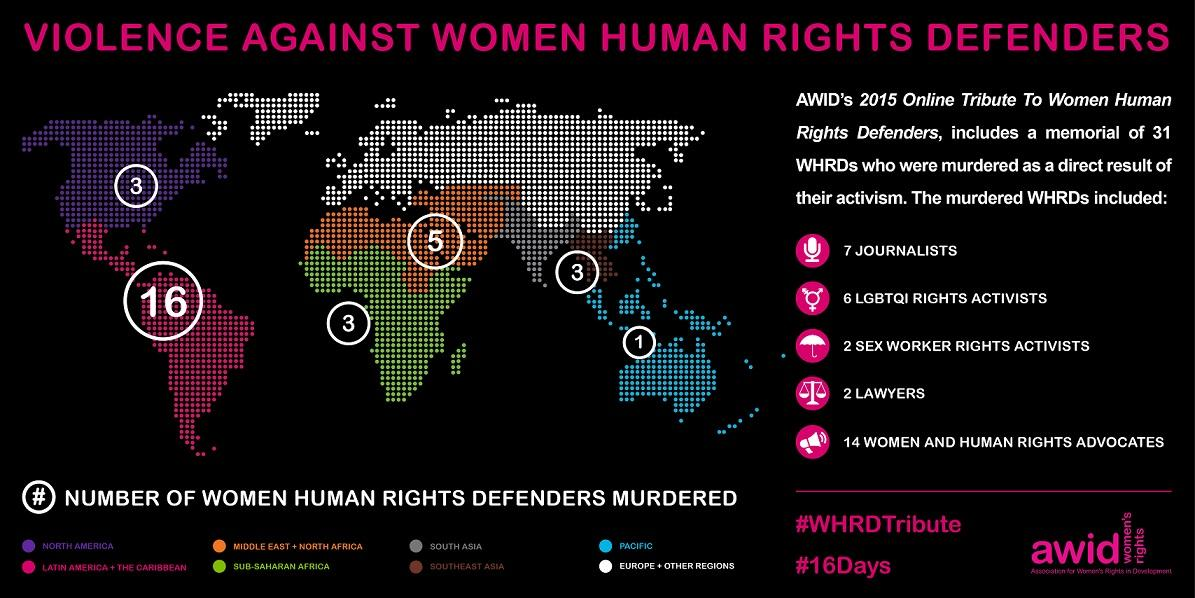Point out several critical features in this image. There have been at least one woman human rights defender murdered in the Pacific. The total number of journalists and lawyers murdered is 9. In Southeast Asia, a total of 5 women human rights defenders have been murdered. According to recent reports, three women human rights defenders have been murdered in North America. According to recent statistics, the number of women human rights defenders murdered in the Middle East and North Africa has increased to 5. 